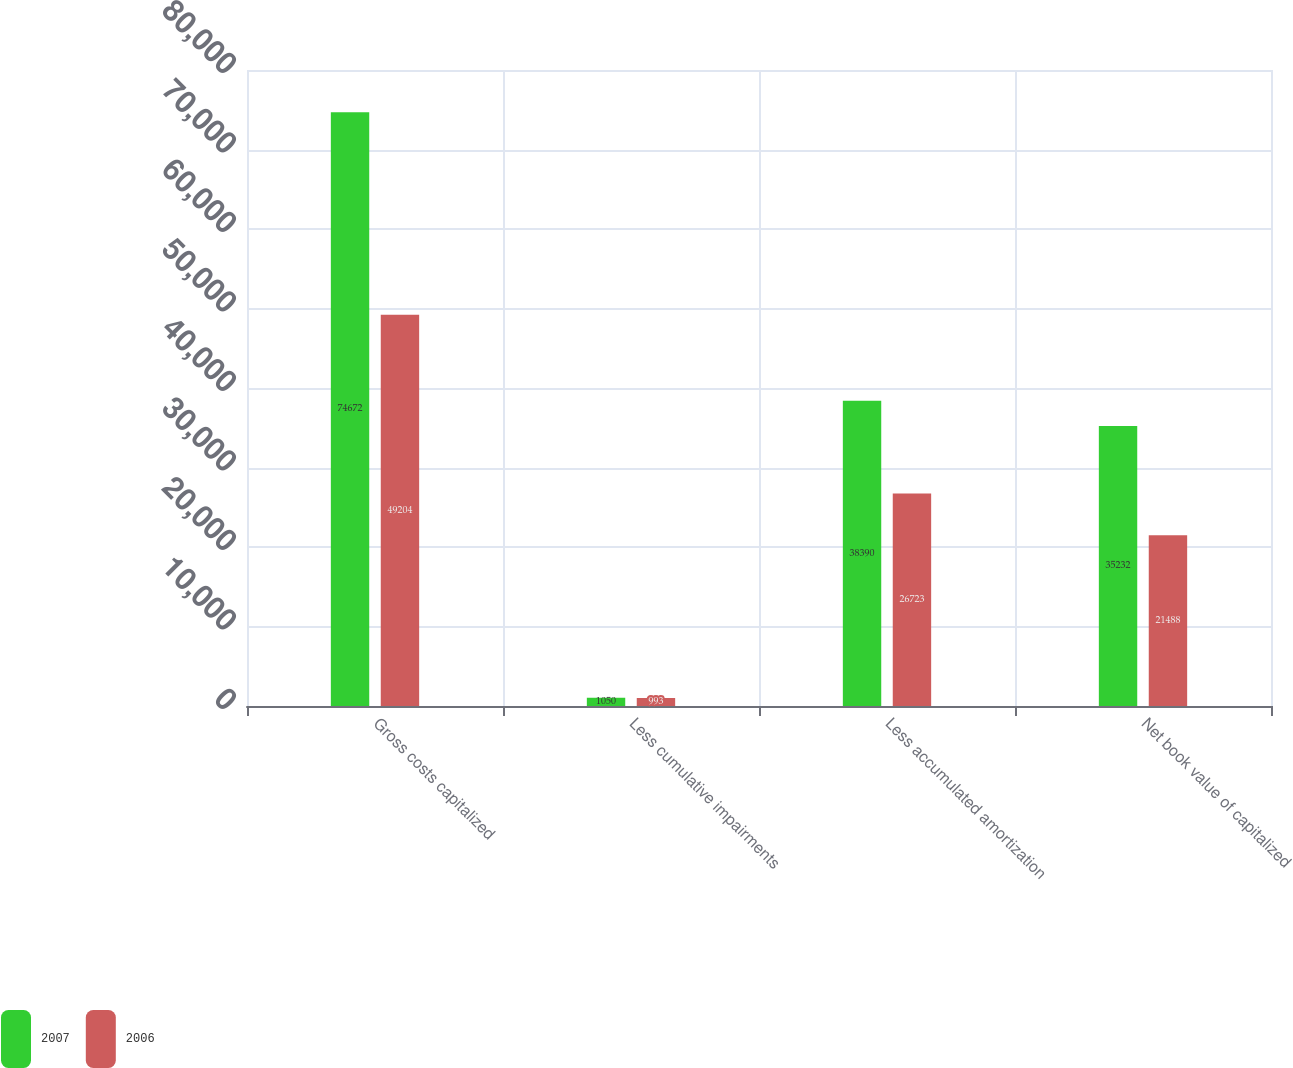Convert chart to OTSL. <chart><loc_0><loc_0><loc_500><loc_500><stacked_bar_chart><ecel><fcel>Gross costs capitalized<fcel>Less cumulative impairments<fcel>Less accumulated amortization<fcel>Net book value of capitalized<nl><fcel>2007<fcel>74672<fcel>1050<fcel>38390<fcel>35232<nl><fcel>2006<fcel>49204<fcel>993<fcel>26723<fcel>21488<nl></chart> 